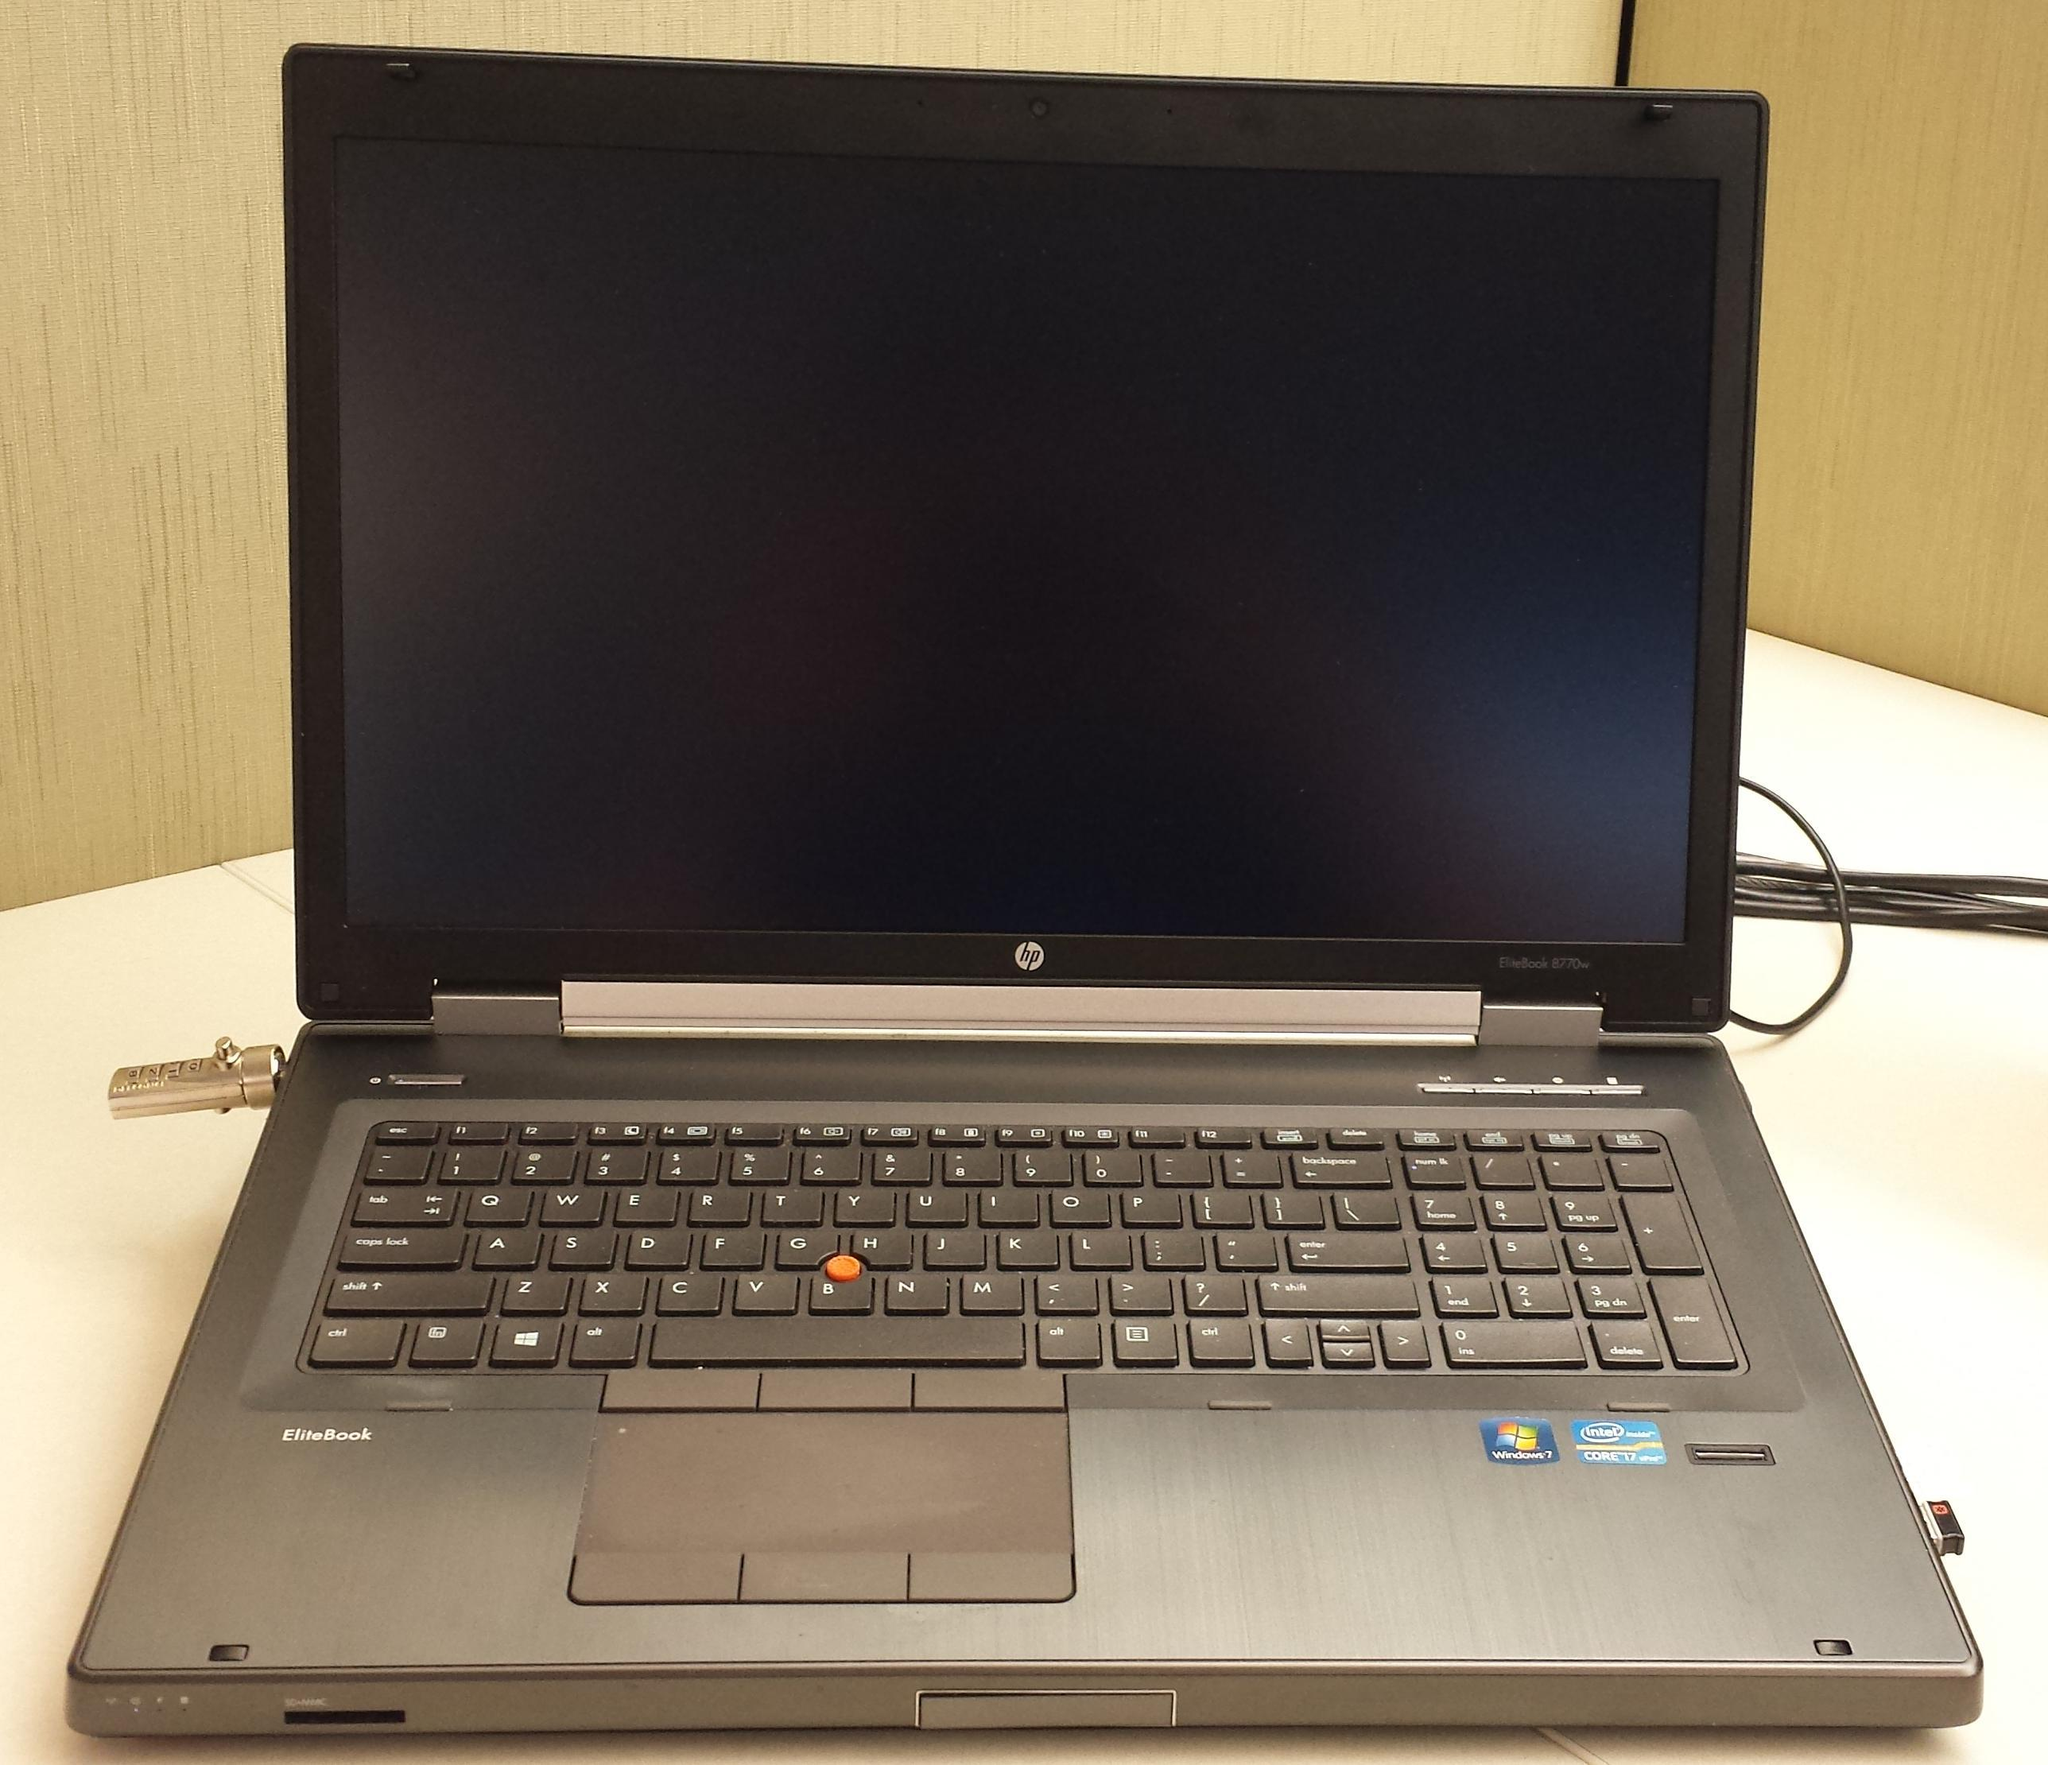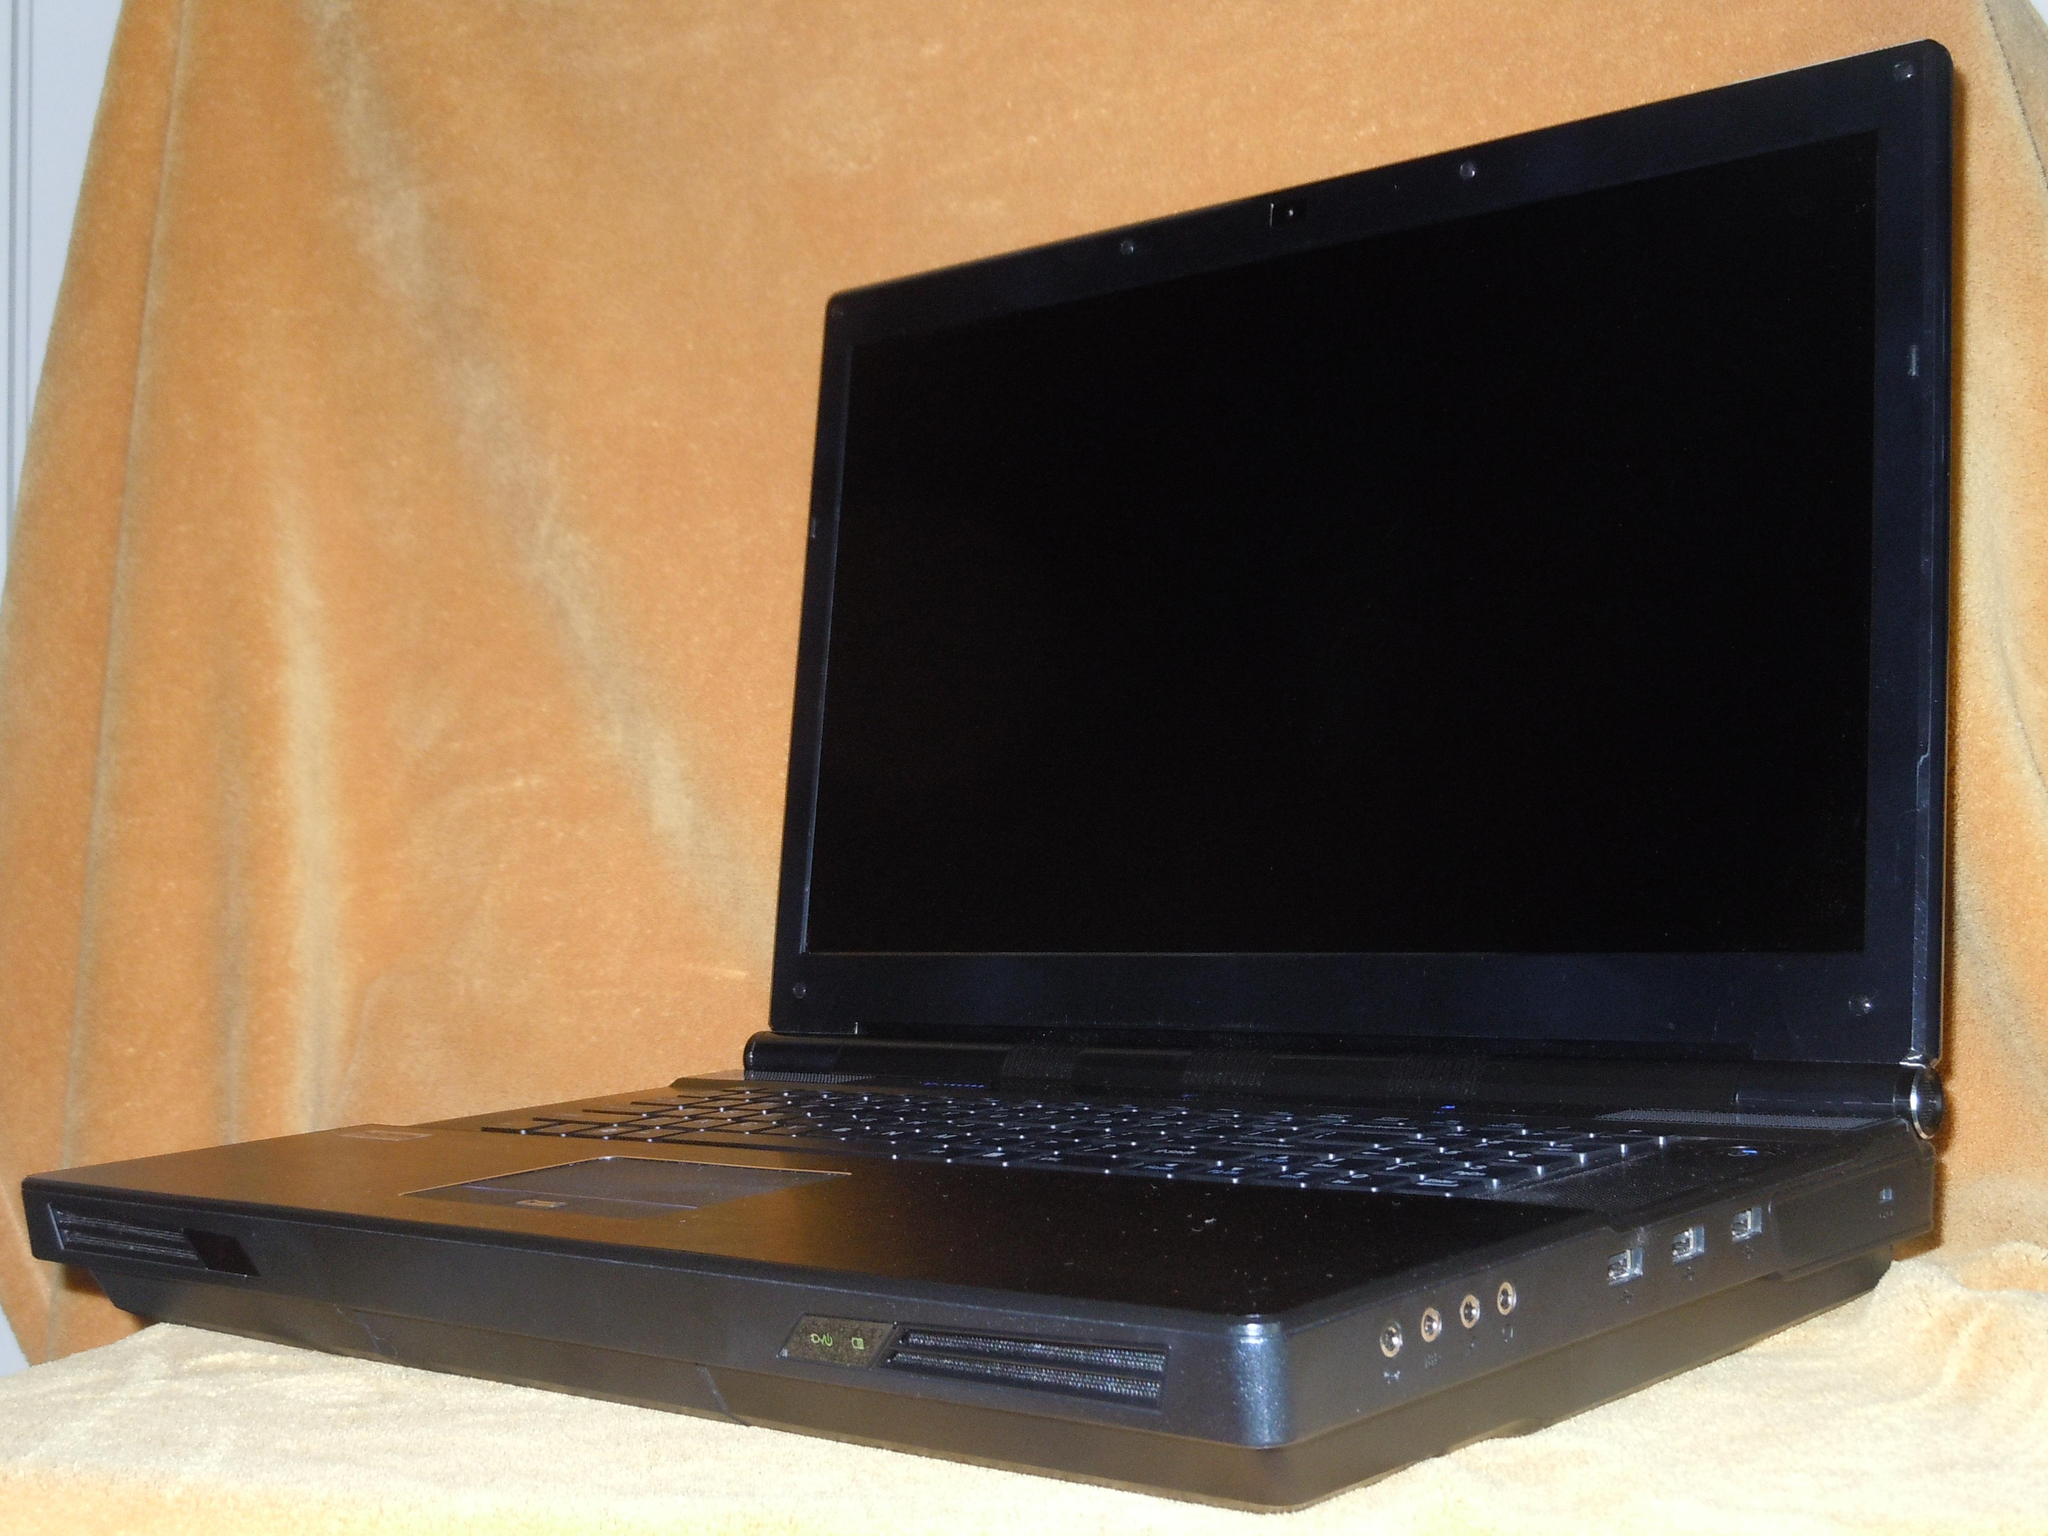The first image is the image on the left, the second image is the image on the right. Given the left and right images, does the statement "there is a laptop with rainbow colored lit up kets and a lit up light in front of the laptops base" hold true? Answer yes or no. No. 